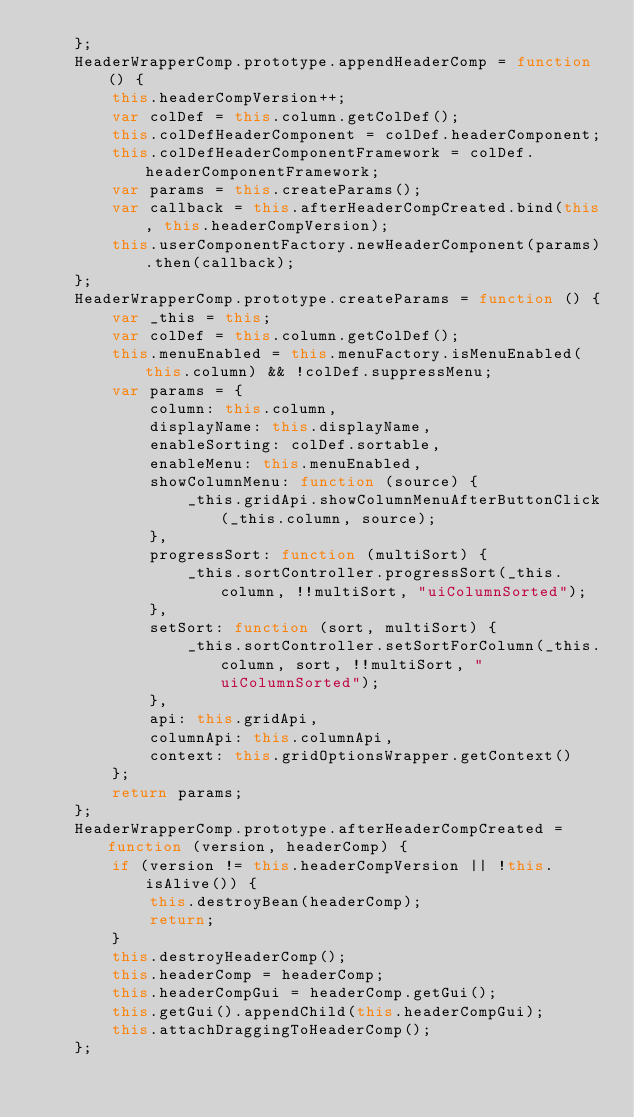<code> <loc_0><loc_0><loc_500><loc_500><_JavaScript_>    };
    HeaderWrapperComp.prototype.appendHeaderComp = function () {
        this.headerCompVersion++;
        var colDef = this.column.getColDef();
        this.colDefHeaderComponent = colDef.headerComponent;
        this.colDefHeaderComponentFramework = colDef.headerComponentFramework;
        var params = this.createParams();
        var callback = this.afterHeaderCompCreated.bind(this, this.headerCompVersion);
        this.userComponentFactory.newHeaderComponent(params).then(callback);
    };
    HeaderWrapperComp.prototype.createParams = function () {
        var _this = this;
        var colDef = this.column.getColDef();
        this.menuEnabled = this.menuFactory.isMenuEnabled(this.column) && !colDef.suppressMenu;
        var params = {
            column: this.column,
            displayName: this.displayName,
            enableSorting: colDef.sortable,
            enableMenu: this.menuEnabled,
            showColumnMenu: function (source) {
                _this.gridApi.showColumnMenuAfterButtonClick(_this.column, source);
            },
            progressSort: function (multiSort) {
                _this.sortController.progressSort(_this.column, !!multiSort, "uiColumnSorted");
            },
            setSort: function (sort, multiSort) {
                _this.sortController.setSortForColumn(_this.column, sort, !!multiSort, "uiColumnSorted");
            },
            api: this.gridApi,
            columnApi: this.columnApi,
            context: this.gridOptionsWrapper.getContext()
        };
        return params;
    };
    HeaderWrapperComp.prototype.afterHeaderCompCreated = function (version, headerComp) {
        if (version != this.headerCompVersion || !this.isAlive()) {
            this.destroyBean(headerComp);
            return;
        }
        this.destroyHeaderComp();
        this.headerComp = headerComp;
        this.headerCompGui = headerComp.getGui();
        this.getGui().appendChild(this.headerCompGui);
        this.attachDraggingToHeaderComp();
    };</code> 